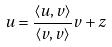<formula> <loc_0><loc_0><loc_500><loc_500>u = \frac { \langle u , v \rangle } { \langle v , v \rangle } v + z</formula> 